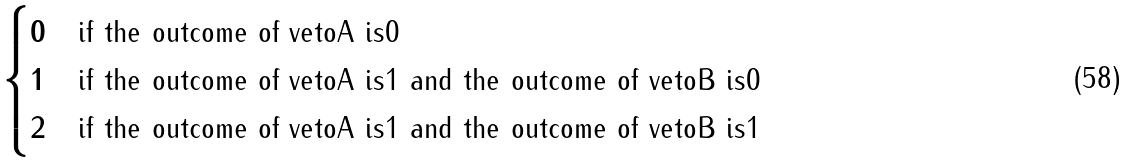Convert formula to latex. <formula><loc_0><loc_0><loc_500><loc_500>\begin{cases} 0 & \text {if the outcome of vetoA is0} \\ 1 & \text {if the outcome of vetoA is1 and the outcome of vetoB is0 } \\ 2 & \text {if the outcome of vetoA is1 and the outcome of vetoB is1} \end{cases}</formula> 